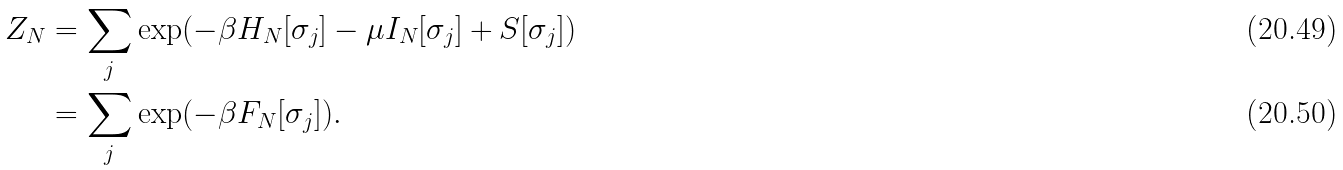Convert formula to latex. <formula><loc_0><loc_0><loc_500><loc_500>Z _ { N } & = \sum _ { j } \exp ( - \beta H _ { N } [ \sigma _ { j } ] - \mu I _ { N } [ \sigma _ { j } ] + S [ \sigma _ { j } ] ) \\ & = \sum _ { j } \exp ( - \beta F _ { N } [ \sigma _ { j } ] ) .</formula> 